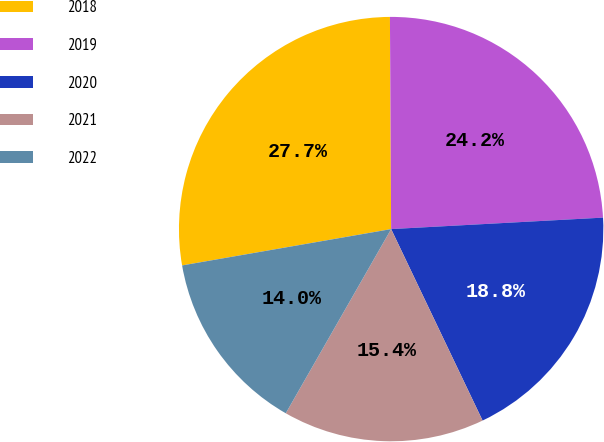<chart> <loc_0><loc_0><loc_500><loc_500><pie_chart><fcel>2018<fcel>2019<fcel>2020<fcel>2021<fcel>2022<nl><fcel>27.65%<fcel>24.23%<fcel>18.77%<fcel>15.36%<fcel>13.99%<nl></chart> 